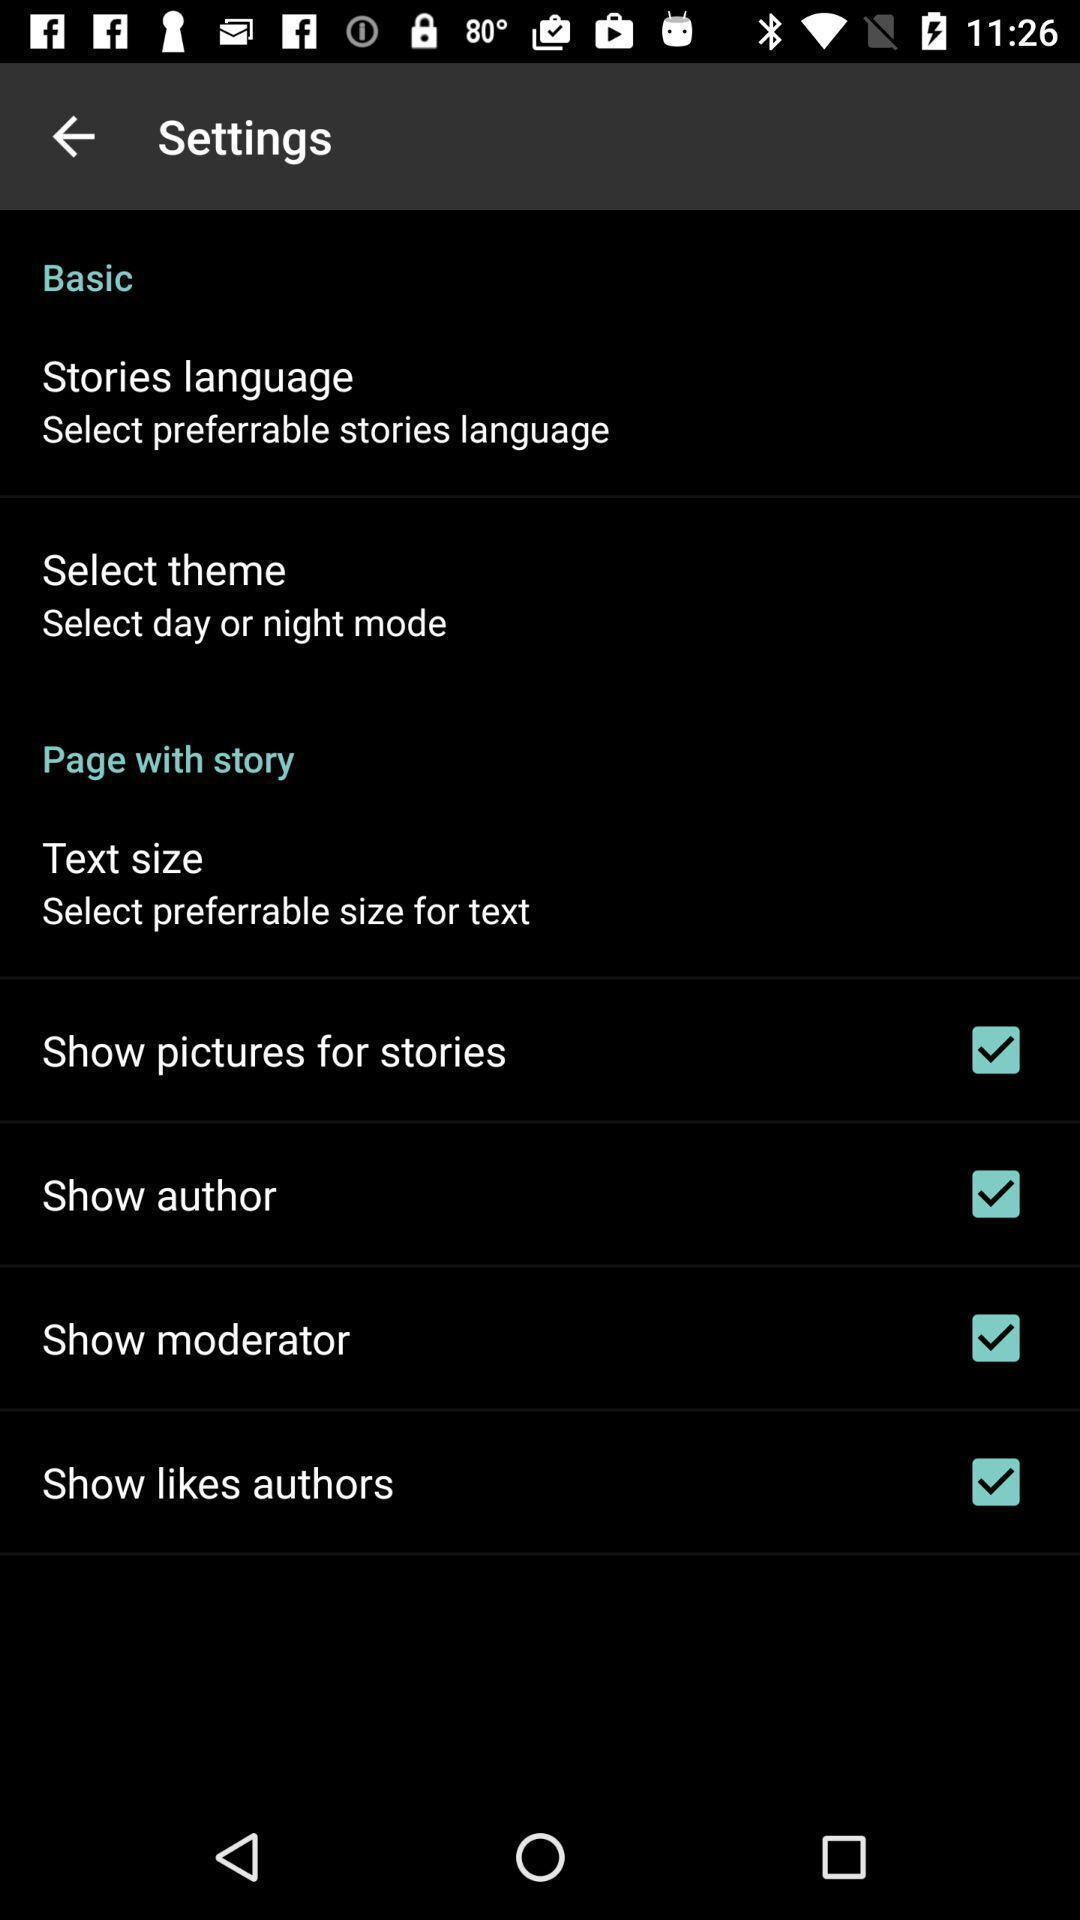Provide a textual representation of this image. Settings page with various options. 